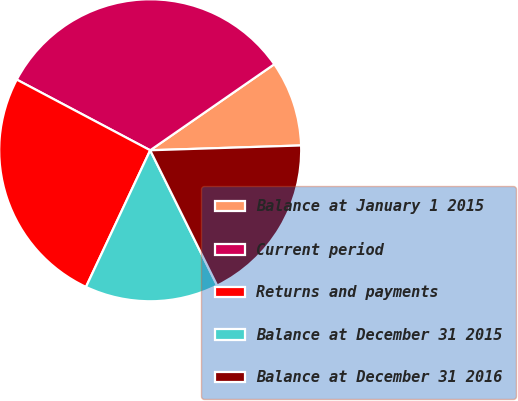<chart> <loc_0><loc_0><loc_500><loc_500><pie_chart><fcel>Balance at January 1 2015<fcel>Current period<fcel>Returns and payments<fcel>Balance at December 31 2015<fcel>Balance at December 31 2016<nl><fcel>9.14%<fcel>32.6%<fcel>25.76%<fcel>14.31%<fcel>18.19%<nl></chart> 